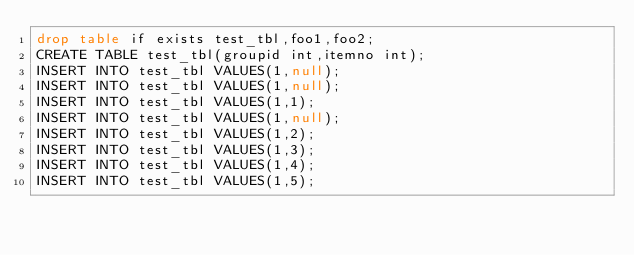<code> <loc_0><loc_0><loc_500><loc_500><_SQL_>drop table if exists test_tbl,foo1,foo2;
CREATE TABLE test_tbl(groupid int,itemno int);
INSERT INTO test_tbl VALUES(1,null);
INSERT INTO test_tbl VALUES(1,null);
INSERT INTO test_tbl VALUES(1,1);
INSERT INTO test_tbl VALUES(1,null);
INSERT INTO test_tbl VALUES(1,2);
INSERT INTO test_tbl VALUES(1,3);
INSERT INTO test_tbl VALUES(1,4);
INSERT INTO test_tbl VALUES(1,5);</code> 